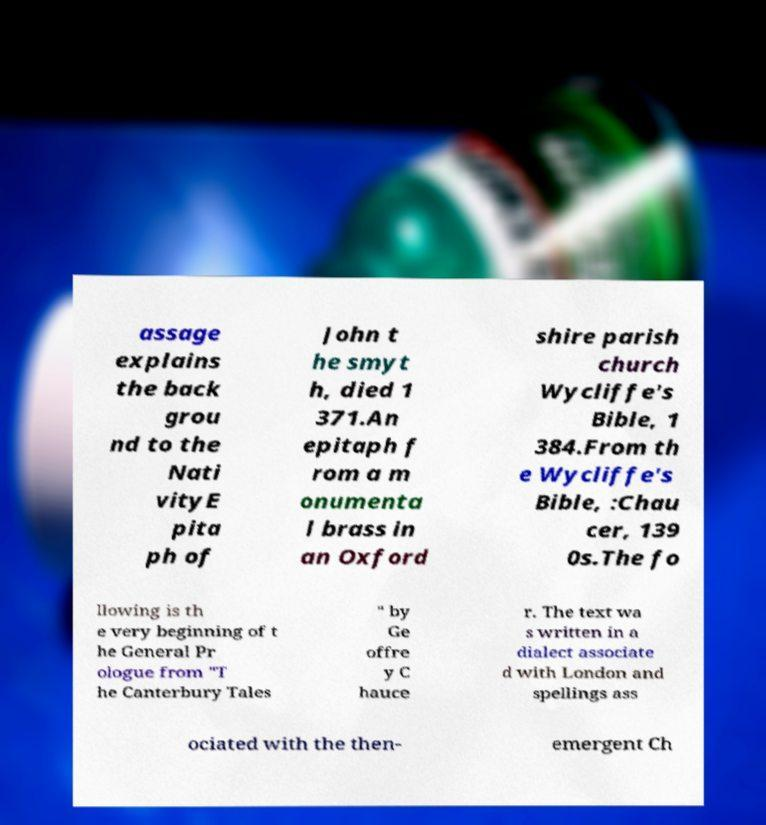Could you assist in decoding the text presented in this image and type it out clearly? assage explains the back grou nd to the Nati vityE pita ph of John t he smyt h, died 1 371.An epitaph f rom a m onumenta l brass in an Oxford shire parish church Wycliffe's Bible, 1 384.From th e Wycliffe's Bible, :Chau cer, 139 0s.The fo llowing is th e very beginning of t he General Pr ologue from "T he Canterbury Tales " by Ge offre y C hauce r. The text wa s written in a dialect associate d with London and spellings ass ociated with the then- emergent Ch 